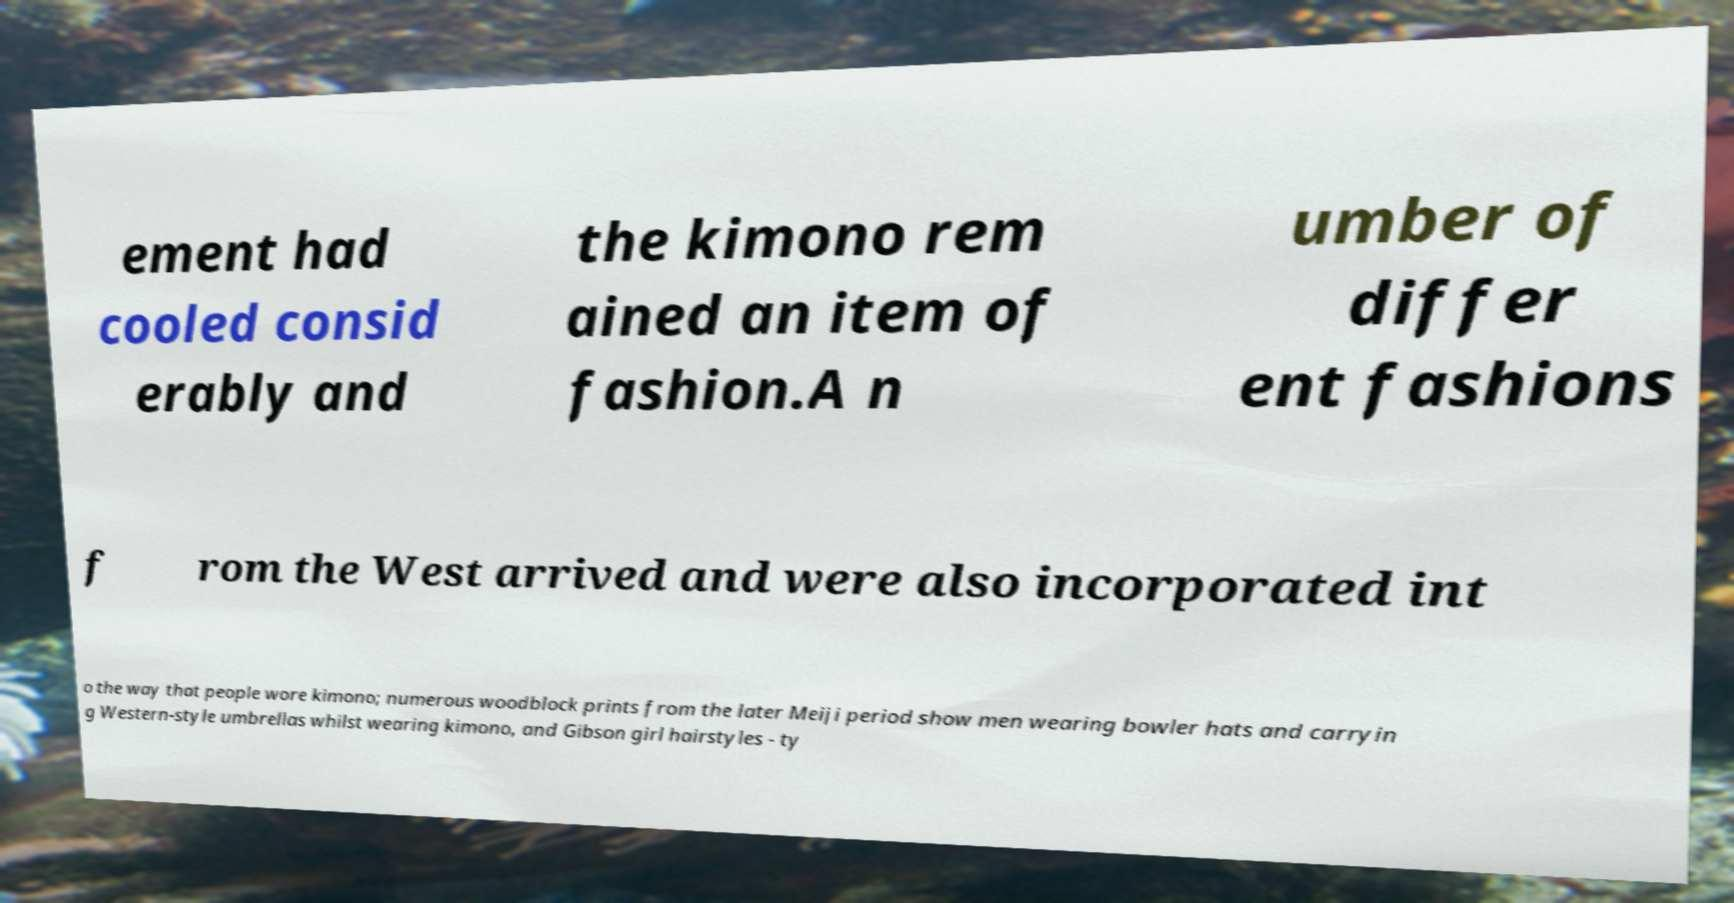I need the written content from this picture converted into text. Can you do that? ement had cooled consid erably and the kimono rem ained an item of fashion.A n umber of differ ent fashions f rom the West arrived and were also incorporated int o the way that people wore kimono; numerous woodblock prints from the later Meiji period show men wearing bowler hats and carryin g Western-style umbrellas whilst wearing kimono, and Gibson girl hairstyles - ty 